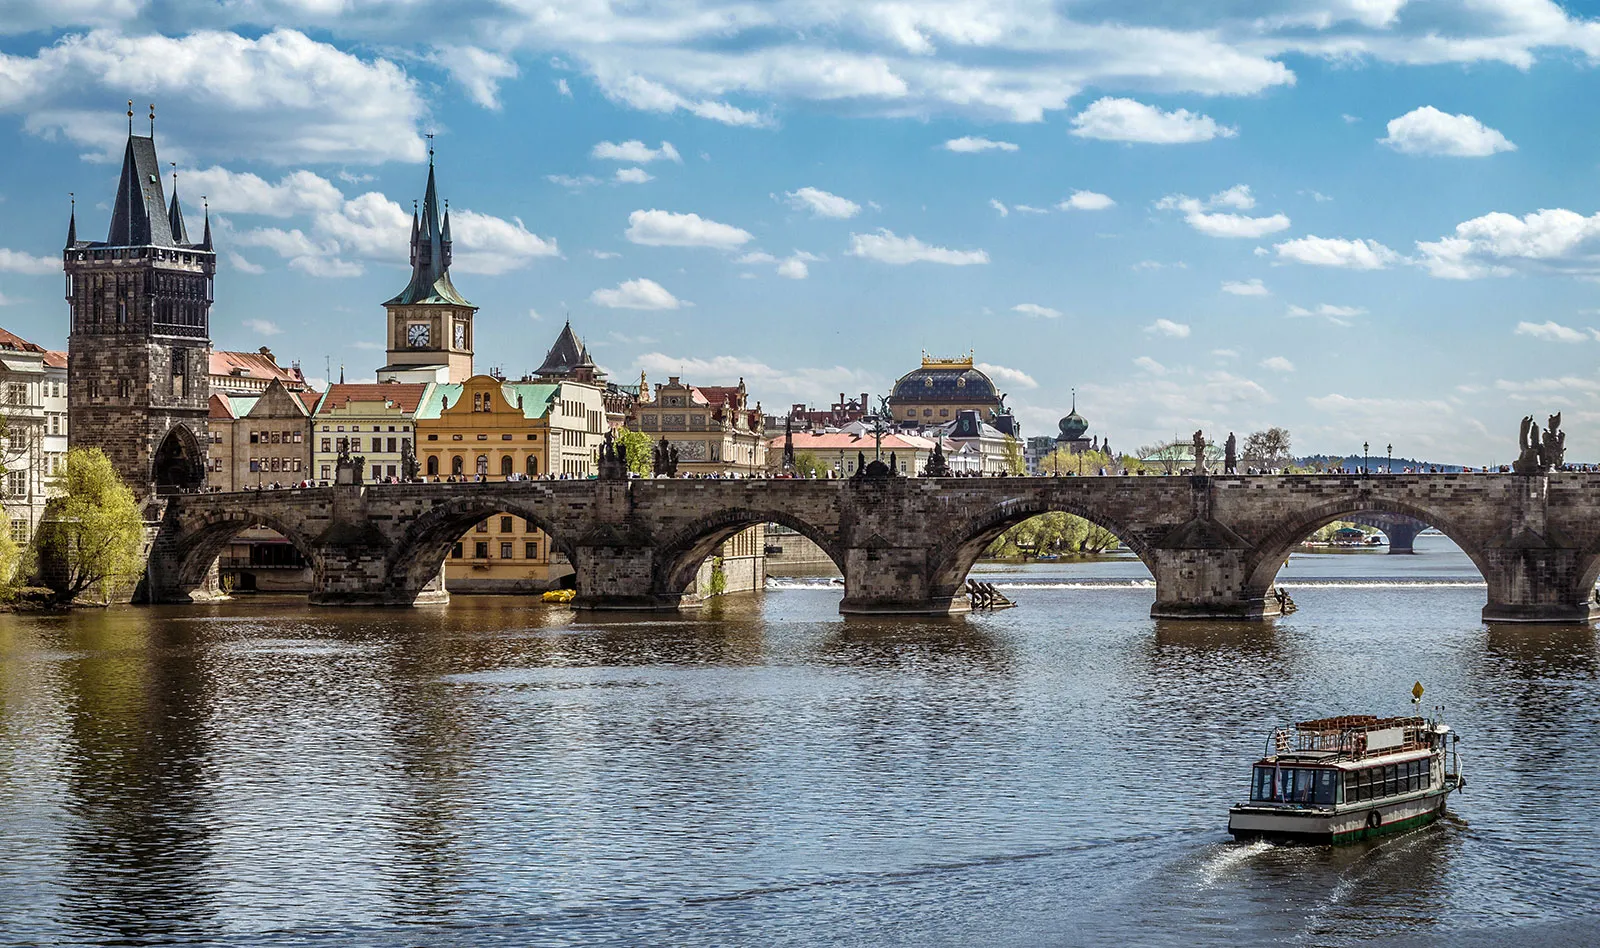Describe the types of activities that locals and tourists engage in around Charles Bridge. Charles Bridge is a vibrant locale teeming with activity. Artists set up easels to capture its picturesque views, musicians and street performers entertain passing crowds, and vendors sell souvenirs and local crafts. It's also a beloved spot for photographers and romantic strolls, especially at dawn or dusk when the city's skyline creates a stunning backdrop. 